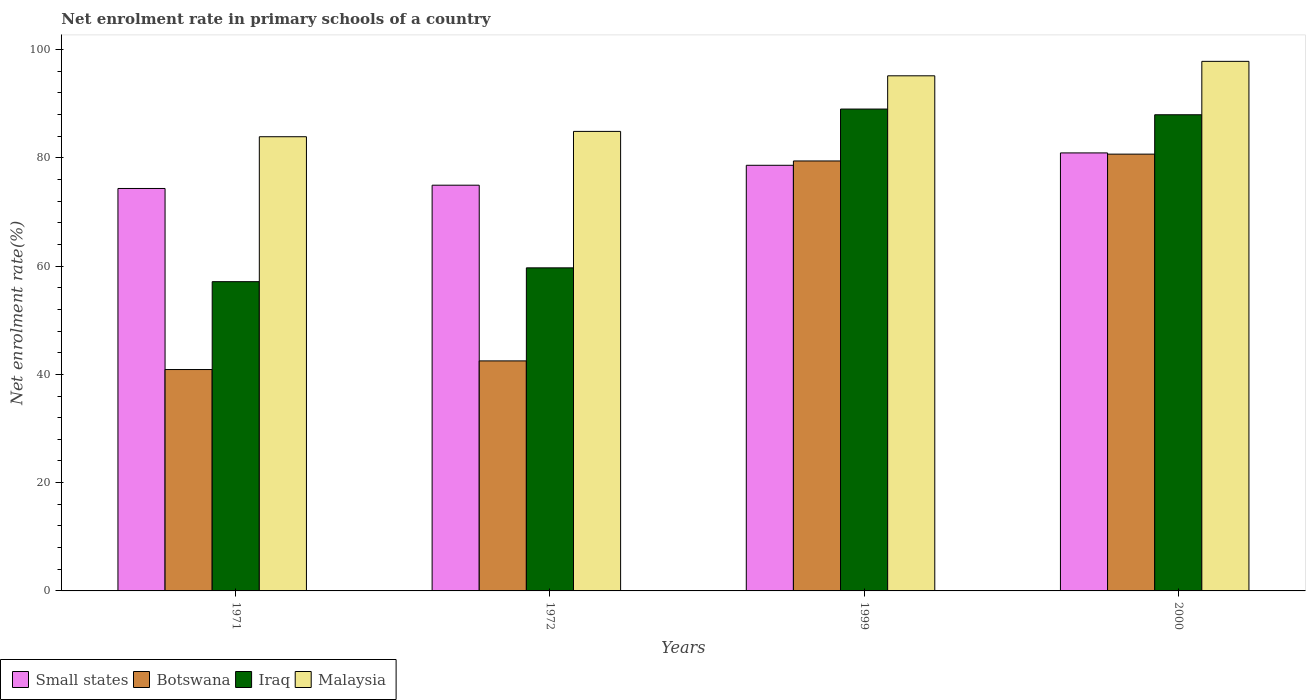How many different coloured bars are there?
Your answer should be compact. 4. Are the number of bars per tick equal to the number of legend labels?
Offer a very short reply. Yes. Are the number of bars on each tick of the X-axis equal?
Your response must be concise. Yes. How many bars are there on the 2nd tick from the right?
Your answer should be compact. 4. What is the net enrolment rate in primary schools in Iraq in 1999?
Offer a very short reply. 89. Across all years, what is the maximum net enrolment rate in primary schools in Iraq?
Ensure brevity in your answer.  89. Across all years, what is the minimum net enrolment rate in primary schools in Iraq?
Offer a terse response. 57.12. In which year was the net enrolment rate in primary schools in Malaysia maximum?
Ensure brevity in your answer.  2000. What is the total net enrolment rate in primary schools in Malaysia in the graph?
Your response must be concise. 361.73. What is the difference between the net enrolment rate in primary schools in Malaysia in 1972 and that in 2000?
Provide a short and direct response. -12.94. What is the difference between the net enrolment rate in primary schools in Small states in 2000 and the net enrolment rate in primary schools in Iraq in 1999?
Keep it short and to the point. -8.1. What is the average net enrolment rate in primary schools in Small states per year?
Your answer should be compact. 77.2. In the year 1972, what is the difference between the net enrolment rate in primary schools in Botswana and net enrolment rate in primary schools in Malaysia?
Offer a very short reply. -42.39. In how many years, is the net enrolment rate in primary schools in Malaysia greater than 20 %?
Make the answer very short. 4. What is the ratio of the net enrolment rate in primary schools in Iraq in 1971 to that in 1972?
Your response must be concise. 0.96. Is the difference between the net enrolment rate in primary schools in Botswana in 1971 and 2000 greater than the difference between the net enrolment rate in primary schools in Malaysia in 1971 and 2000?
Make the answer very short. No. What is the difference between the highest and the second highest net enrolment rate in primary schools in Malaysia?
Provide a succinct answer. 2.67. What is the difference between the highest and the lowest net enrolment rate in primary schools in Botswana?
Give a very brief answer. 39.79. What does the 3rd bar from the left in 1972 represents?
Ensure brevity in your answer.  Iraq. What does the 1st bar from the right in 1999 represents?
Keep it short and to the point. Malaysia. Is it the case that in every year, the sum of the net enrolment rate in primary schools in Small states and net enrolment rate in primary schools in Iraq is greater than the net enrolment rate in primary schools in Malaysia?
Provide a succinct answer. Yes. How many bars are there?
Your response must be concise. 16. How many years are there in the graph?
Offer a very short reply. 4. Does the graph contain any zero values?
Offer a terse response. No. Does the graph contain grids?
Make the answer very short. No. Where does the legend appear in the graph?
Give a very brief answer. Bottom left. What is the title of the graph?
Your response must be concise. Net enrolment rate in primary schools of a country. What is the label or title of the Y-axis?
Provide a succinct answer. Net enrolment rate(%). What is the Net enrolment rate(%) of Small states in 1971?
Provide a short and direct response. 74.33. What is the Net enrolment rate(%) of Botswana in 1971?
Ensure brevity in your answer.  40.89. What is the Net enrolment rate(%) of Iraq in 1971?
Provide a short and direct response. 57.12. What is the Net enrolment rate(%) of Malaysia in 1971?
Keep it short and to the point. 83.89. What is the Net enrolment rate(%) in Small states in 1972?
Provide a succinct answer. 74.94. What is the Net enrolment rate(%) of Botswana in 1972?
Provide a succinct answer. 42.49. What is the Net enrolment rate(%) of Iraq in 1972?
Make the answer very short. 59.67. What is the Net enrolment rate(%) of Malaysia in 1972?
Offer a very short reply. 84.88. What is the Net enrolment rate(%) in Small states in 1999?
Give a very brief answer. 78.62. What is the Net enrolment rate(%) in Botswana in 1999?
Offer a very short reply. 79.42. What is the Net enrolment rate(%) of Iraq in 1999?
Ensure brevity in your answer.  89. What is the Net enrolment rate(%) in Malaysia in 1999?
Make the answer very short. 95.14. What is the Net enrolment rate(%) in Small states in 2000?
Give a very brief answer. 80.9. What is the Net enrolment rate(%) in Botswana in 2000?
Offer a terse response. 80.68. What is the Net enrolment rate(%) in Iraq in 2000?
Your response must be concise. 87.95. What is the Net enrolment rate(%) in Malaysia in 2000?
Offer a terse response. 97.81. Across all years, what is the maximum Net enrolment rate(%) in Small states?
Keep it short and to the point. 80.9. Across all years, what is the maximum Net enrolment rate(%) of Botswana?
Your response must be concise. 80.68. Across all years, what is the maximum Net enrolment rate(%) in Iraq?
Make the answer very short. 89. Across all years, what is the maximum Net enrolment rate(%) of Malaysia?
Your answer should be compact. 97.81. Across all years, what is the minimum Net enrolment rate(%) of Small states?
Your response must be concise. 74.33. Across all years, what is the minimum Net enrolment rate(%) of Botswana?
Ensure brevity in your answer.  40.89. Across all years, what is the minimum Net enrolment rate(%) of Iraq?
Give a very brief answer. 57.12. Across all years, what is the minimum Net enrolment rate(%) of Malaysia?
Provide a succinct answer. 83.89. What is the total Net enrolment rate(%) in Small states in the graph?
Give a very brief answer. 308.79. What is the total Net enrolment rate(%) in Botswana in the graph?
Your answer should be compact. 243.47. What is the total Net enrolment rate(%) in Iraq in the graph?
Ensure brevity in your answer.  293.75. What is the total Net enrolment rate(%) of Malaysia in the graph?
Give a very brief answer. 361.73. What is the difference between the Net enrolment rate(%) of Small states in 1971 and that in 1972?
Provide a succinct answer. -0.61. What is the difference between the Net enrolment rate(%) in Botswana in 1971 and that in 1972?
Your answer should be very brief. -1.6. What is the difference between the Net enrolment rate(%) of Iraq in 1971 and that in 1972?
Your answer should be compact. -2.55. What is the difference between the Net enrolment rate(%) of Malaysia in 1971 and that in 1972?
Your answer should be very brief. -0.99. What is the difference between the Net enrolment rate(%) in Small states in 1971 and that in 1999?
Your answer should be very brief. -4.28. What is the difference between the Net enrolment rate(%) in Botswana in 1971 and that in 1999?
Ensure brevity in your answer.  -38.53. What is the difference between the Net enrolment rate(%) of Iraq in 1971 and that in 1999?
Keep it short and to the point. -31.88. What is the difference between the Net enrolment rate(%) of Malaysia in 1971 and that in 1999?
Make the answer very short. -11.25. What is the difference between the Net enrolment rate(%) in Small states in 1971 and that in 2000?
Your response must be concise. -6.57. What is the difference between the Net enrolment rate(%) in Botswana in 1971 and that in 2000?
Provide a short and direct response. -39.79. What is the difference between the Net enrolment rate(%) in Iraq in 1971 and that in 2000?
Provide a succinct answer. -30.83. What is the difference between the Net enrolment rate(%) in Malaysia in 1971 and that in 2000?
Offer a terse response. -13.92. What is the difference between the Net enrolment rate(%) in Small states in 1972 and that in 1999?
Ensure brevity in your answer.  -3.68. What is the difference between the Net enrolment rate(%) in Botswana in 1972 and that in 1999?
Make the answer very short. -36.93. What is the difference between the Net enrolment rate(%) in Iraq in 1972 and that in 1999?
Ensure brevity in your answer.  -29.33. What is the difference between the Net enrolment rate(%) in Malaysia in 1972 and that in 1999?
Offer a terse response. -10.27. What is the difference between the Net enrolment rate(%) in Small states in 1972 and that in 2000?
Provide a succinct answer. -5.96. What is the difference between the Net enrolment rate(%) of Botswana in 1972 and that in 2000?
Make the answer very short. -38.19. What is the difference between the Net enrolment rate(%) of Iraq in 1972 and that in 2000?
Provide a succinct answer. -28.28. What is the difference between the Net enrolment rate(%) of Malaysia in 1972 and that in 2000?
Offer a very short reply. -12.94. What is the difference between the Net enrolment rate(%) of Small states in 1999 and that in 2000?
Make the answer very short. -2.28. What is the difference between the Net enrolment rate(%) of Botswana in 1999 and that in 2000?
Give a very brief answer. -1.26. What is the difference between the Net enrolment rate(%) in Iraq in 1999 and that in 2000?
Provide a short and direct response. 1.05. What is the difference between the Net enrolment rate(%) in Malaysia in 1999 and that in 2000?
Offer a very short reply. -2.67. What is the difference between the Net enrolment rate(%) of Small states in 1971 and the Net enrolment rate(%) of Botswana in 1972?
Provide a succinct answer. 31.85. What is the difference between the Net enrolment rate(%) in Small states in 1971 and the Net enrolment rate(%) in Iraq in 1972?
Provide a succinct answer. 14.66. What is the difference between the Net enrolment rate(%) in Small states in 1971 and the Net enrolment rate(%) in Malaysia in 1972?
Make the answer very short. -10.54. What is the difference between the Net enrolment rate(%) in Botswana in 1971 and the Net enrolment rate(%) in Iraq in 1972?
Make the answer very short. -18.78. What is the difference between the Net enrolment rate(%) in Botswana in 1971 and the Net enrolment rate(%) in Malaysia in 1972?
Provide a short and direct response. -43.99. What is the difference between the Net enrolment rate(%) in Iraq in 1971 and the Net enrolment rate(%) in Malaysia in 1972?
Offer a terse response. -27.76. What is the difference between the Net enrolment rate(%) of Small states in 1971 and the Net enrolment rate(%) of Botswana in 1999?
Offer a terse response. -5.08. What is the difference between the Net enrolment rate(%) in Small states in 1971 and the Net enrolment rate(%) in Iraq in 1999?
Provide a short and direct response. -14.67. What is the difference between the Net enrolment rate(%) of Small states in 1971 and the Net enrolment rate(%) of Malaysia in 1999?
Offer a very short reply. -20.81. What is the difference between the Net enrolment rate(%) in Botswana in 1971 and the Net enrolment rate(%) in Iraq in 1999?
Your response must be concise. -48.11. What is the difference between the Net enrolment rate(%) of Botswana in 1971 and the Net enrolment rate(%) of Malaysia in 1999?
Offer a very short reply. -54.26. What is the difference between the Net enrolment rate(%) of Iraq in 1971 and the Net enrolment rate(%) of Malaysia in 1999?
Ensure brevity in your answer.  -38.02. What is the difference between the Net enrolment rate(%) of Small states in 1971 and the Net enrolment rate(%) of Botswana in 2000?
Offer a very short reply. -6.34. What is the difference between the Net enrolment rate(%) of Small states in 1971 and the Net enrolment rate(%) of Iraq in 2000?
Provide a succinct answer. -13.62. What is the difference between the Net enrolment rate(%) in Small states in 1971 and the Net enrolment rate(%) in Malaysia in 2000?
Make the answer very short. -23.48. What is the difference between the Net enrolment rate(%) in Botswana in 1971 and the Net enrolment rate(%) in Iraq in 2000?
Provide a succinct answer. -47.06. What is the difference between the Net enrolment rate(%) in Botswana in 1971 and the Net enrolment rate(%) in Malaysia in 2000?
Give a very brief answer. -56.92. What is the difference between the Net enrolment rate(%) of Iraq in 1971 and the Net enrolment rate(%) of Malaysia in 2000?
Offer a terse response. -40.69. What is the difference between the Net enrolment rate(%) in Small states in 1972 and the Net enrolment rate(%) in Botswana in 1999?
Your answer should be very brief. -4.48. What is the difference between the Net enrolment rate(%) of Small states in 1972 and the Net enrolment rate(%) of Iraq in 1999?
Your response must be concise. -14.06. What is the difference between the Net enrolment rate(%) in Small states in 1972 and the Net enrolment rate(%) in Malaysia in 1999?
Ensure brevity in your answer.  -20.2. What is the difference between the Net enrolment rate(%) of Botswana in 1972 and the Net enrolment rate(%) of Iraq in 1999?
Ensure brevity in your answer.  -46.52. What is the difference between the Net enrolment rate(%) in Botswana in 1972 and the Net enrolment rate(%) in Malaysia in 1999?
Your response must be concise. -52.66. What is the difference between the Net enrolment rate(%) of Iraq in 1972 and the Net enrolment rate(%) of Malaysia in 1999?
Your answer should be compact. -35.47. What is the difference between the Net enrolment rate(%) in Small states in 1972 and the Net enrolment rate(%) in Botswana in 2000?
Keep it short and to the point. -5.74. What is the difference between the Net enrolment rate(%) of Small states in 1972 and the Net enrolment rate(%) of Iraq in 2000?
Give a very brief answer. -13.01. What is the difference between the Net enrolment rate(%) of Small states in 1972 and the Net enrolment rate(%) of Malaysia in 2000?
Ensure brevity in your answer.  -22.87. What is the difference between the Net enrolment rate(%) in Botswana in 1972 and the Net enrolment rate(%) in Iraq in 2000?
Ensure brevity in your answer.  -45.46. What is the difference between the Net enrolment rate(%) of Botswana in 1972 and the Net enrolment rate(%) of Malaysia in 2000?
Provide a short and direct response. -55.33. What is the difference between the Net enrolment rate(%) in Iraq in 1972 and the Net enrolment rate(%) in Malaysia in 2000?
Give a very brief answer. -38.14. What is the difference between the Net enrolment rate(%) in Small states in 1999 and the Net enrolment rate(%) in Botswana in 2000?
Your answer should be very brief. -2.06. What is the difference between the Net enrolment rate(%) of Small states in 1999 and the Net enrolment rate(%) of Iraq in 2000?
Your answer should be very brief. -9.33. What is the difference between the Net enrolment rate(%) of Small states in 1999 and the Net enrolment rate(%) of Malaysia in 2000?
Offer a very short reply. -19.2. What is the difference between the Net enrolment rate(%) in Botswana in 1999 and the Net enrolment rate(%) in Iraq in 2000?
Offer a very short reply. -8.54. What is the difference between the Net enrolment rate(%) in Botswana in 1999 and the Net enrolment rate(%) in Malaysia in 2000?
Your answer should be compact. -18.4. What is the difference between the Net enrolment rate(%) in Iraq in 1999 and the Net enrolment rate(%) in Malaysia in 2000?
Offer a very short reply. -8.81. What is the average Net enrolment rate(%) in Small states per year?
Offer a very short reply. 77.2. What is the average Net enrolment rate(%) of Botswana per year?
Offer a terse response. 60.87. What is the average Net enrolment rate(%) of Iraq per year?
Ensure brevity in your answer.  73.44. What is the average Net enrolment rate(%) in Malaysia per year?
Your answer should be very brief. 90.43. In the year 1971, what is the difference between the Net enrolment rate(%) in Small states and Net enrolment rate(%) in Botswana?
Offer a very short reply. 33.44. In the year 1971, what is the difference between the Net enrolment rate(%) of Small states and Net enrolment rate(%) of Iraq?
Give a very brief answer. 17.21. In the year 1971, what is the difference between the Net enrolment rate(%) in Small states and Net enrolment rate(%) in Malaysia?
Ensure brevity in your answer.  -9.56. In the year 1971, what is the difference between the Net enrolment rate(%) in Botswana and Net enrolment rate(%) in Iraq?
Your answer should be very brief. -16.23. In the year 1971, what is the difference between the Net enrolment rate(%) of Botswana and Net enrolment rate(%) of Malaysia?
Ensure brevity in your answer.  -43. In the year 1971, what is the difference between the Net enrolment rate(%) of Iraq and Net enrolment rate(%) of Malaysia?
Give a very brief answer. -26.77. In the year 1972, what is the difference between the Net enrolment rate(%) in Small states and Net enrolment rate(%) in Botswana?
Your answer should be compact. 32.45. In the year 1972, what is the difference between the Net enrolment rate(%) of Small states and Net enrolment rate(%) of Iraq?
Offer a terse response. 15.27. In the year 1972, what is the difference between the Net enrolment rate(%) of Small states and Net enrolment rate(%) of Malaysia?
Offer a terse response. -9.94. In the year 1972, what is the difference between the Net enrolment rate(%) of Botswana and Net enrolment rate(%) of Iraq?
Offer a terse response. -17.19. In the year 1972, what is the difference between the Net enrolment rate(%) of Botswana and Net enrolment rate(%) of Malaysia?
Make the answer very short. -42.39. In the year 1972, what is the difference between the Net enrolment rate(%) of Iraq and Net enrolment rate(%) of Malaysia?
Make the answer very short. -25.2. In the year 1999, what is the difference between the Net enrolment rate(%) in Small states and Net enrolment rate(%) in Botswana?
Your answer should be very brief. -0.8. In the year 1999, what is the difference between the Net enrolment rate(%) in Small states and Net enrolment rate(%) in Iraq?
Provide a succinct answer. -10.38. In the year 1999, what is the difference between the Net enrolment rate(%) in Small states and Net enrolment rate(%) in Malaysia?
Keep it short and to the point. -16.53. In the year 1999, what is the difference between the Net enrolment rate(%) in Botswana and Net enrolment rate(%) in Iraq?
Make the answer very short. -9.59. In the year 1999, what is the difference between the Net enrolment rate(%) in Botswana and Net enrolment rate(%) in Malaysia?
Offer a terse response. -15.73. In the year 1999, what is the difference between the Net enrolment rate(%) of Iraq and Net enrolment rate(%) of Malaysia?
Provide a short and direct response. -6.14. In the year 2000, what is the difference between the Net enrolment rate(%) of Small states and Net enrolment rate(%) of Botswana?
Make the answer very short. 0.22. In the year 2000, what is the difference between the Net enrolment rate(%) in Small states and Net enrolment rate(%) in Iraq?
Keep it short and to the point. -7.05. In the year 2000, what is the difference between the Net enrolment rate(%) of Small states and Net enrolment rate(%) of Malaysia?
Give a very brief answer. -16.91. In the year 2000, what is the difference between the Net enrolment rate(%) in Botswana and Net enrolment rate(%) in Iraq?
Offer a terse response. -7.27. In the year 2000, what is the difference between the Net enrolment rate(%) of Botswana and Net enrolment rate(%) of Malaysia?
Your answer should be compact. -17.14. In the year 2000, what is the difference between the Net enrolment rate(%) of Iraq and Net enrolment rate(%) of Malaysia?
Your answer should be compact. -9.86. What is the ratio of the Net enrolment rate(%) of Small states in 1971 to that in 1972?
Provide a short and direct response. 0.99. What is the ratio of the Net enrolment rate(%) of Botswana in 1971 to that in 1972?
Ensure brevity in your answer.  0.96. What is the ratio of the Net enrolment rate(%) in Iraq in 1971 to that in 1972?
Give a very brief answer. 0.96. What is the ratio of the Net enrolment rate(%) in Malaysia in 1971 to that in 1972?
Keep it short and to the point. 0.99. What is the ratio of the Net enrolment rate(%) in Small states in 1971 to that in 1999?
Provide a short and direct response. 0.95. What is the ratio of the Net enrolment rate(%) in Botswana in 1971 to that in 1999?
Provide a succinct answer. 0.51. What is the ratio of the Net enrolment rate(%) of Iraq in 1971 to that in 1999?
Keep it short and to the point. 0.64. What is the ratio of the Net enrolment rate(%) of Malaysia in 1971 to that in 1999?
Make the answer very short. 0.88. What is the ratio of the Net enrolment rate(%) of Small states in 1971 to that in 2000?
Give a very brief answer. 0.92. What is the ratio of the Net enrolment rate(%) in Botswana in 1971 to that in 2000?
Make the answer very short. 0.51. What is the ratio of the Net enrolment rate(%) of Iraq in 1971 to that in 2000?
Offer a very short reply. 0.65. What is the ratio of the Net enrolment rate(%) of Malaysia in 1971 to that in 2000?
Your answer should be very brief. 0.86. What is the ratio of the Net enrolment rate(%) of Small states in 1972 to that in 1999?
Keep it short and to the point. 0.95. What is the ratio of the Net enrolment rate(%) in Botswana in 1972 to that in 1999?
Ensure brevity in your answer.  0.54. What is the ratio of the Net enrolment rate(%) of Iraq in 1972 to that in 1999?
Keep it short and to the point. 0.67. What is the ratio of the Net enrolment rate(%) of Malaysia in 1972 to that in 1999?
Offer a very short reply. 0.89. What is the ratio of the Net enrolment rate(%) in Small states in 1972 to that in 2000?
Your answer should be compact. 0.93. What is the ratio of the Net enrolment rate(%) in Botswana in 1972 to that in 2000?
Ensure brevity in your answer.  0.53. What is the ratio of the Net enrolment rate(%) in Iraq in 1972 to that in 2000?
Offer a terse response. 0.68. What is the ratio of the Net enrolment rate(%) of Malaysia in 1972 to that in 2000?
Provide a short and direct response. 0.87. What is the ratio of the Net enrolment rate(%) of Small states in 1999 to that in 2000?
Your answer should be compact. 0.97. What is the ratio of the Net enrolment rate(%) in Botswana in 1999 to that in 2000?
Make the answer very short. 0.98. What is the ratio of the Net enrolment rate(%) in Iraq in 1999 to that in 2000?
Offer a terse response. 1.01. What is the ratio of the Net enrolment rate(%) in Malaysia in 1999 to that in 2000?
Your answer should be compact. 0.97. What is the difference between the highest and the second highest Net enrolment rate(%) of Small states?
Offer a very short reply. 2.28. What is the difference between the highest and the second highest Net enrolment rate(%) of Botswana?
Make the answer very short. 1.26. What is the difference between the highest and the second highest Net enrolment rate(%) of Iraq?
Give a very brief answer. 1.05. What is the difference between the highest and the second highest Net enrolment rate(%) in Malaysia?
Ensure brevity in your answer.  2.67. What is the difference between the highest and the lowest Net enrolment rate(%) in Small states?
Provide a short and direct response. 6.57. What is the difference between the highest and the lowest Net enrolment rate(%) of Botswana?
Ensure brevity in your answer.  39.79. What is the difference between the highest and the lowest Net enrolment rate(%) of Iraq?
Offer a very short reply. 31.88. What is the difference between the highest and the lowest Net enrolment rate(%) in Malaysia?
Offer a terse response. 13.92. 